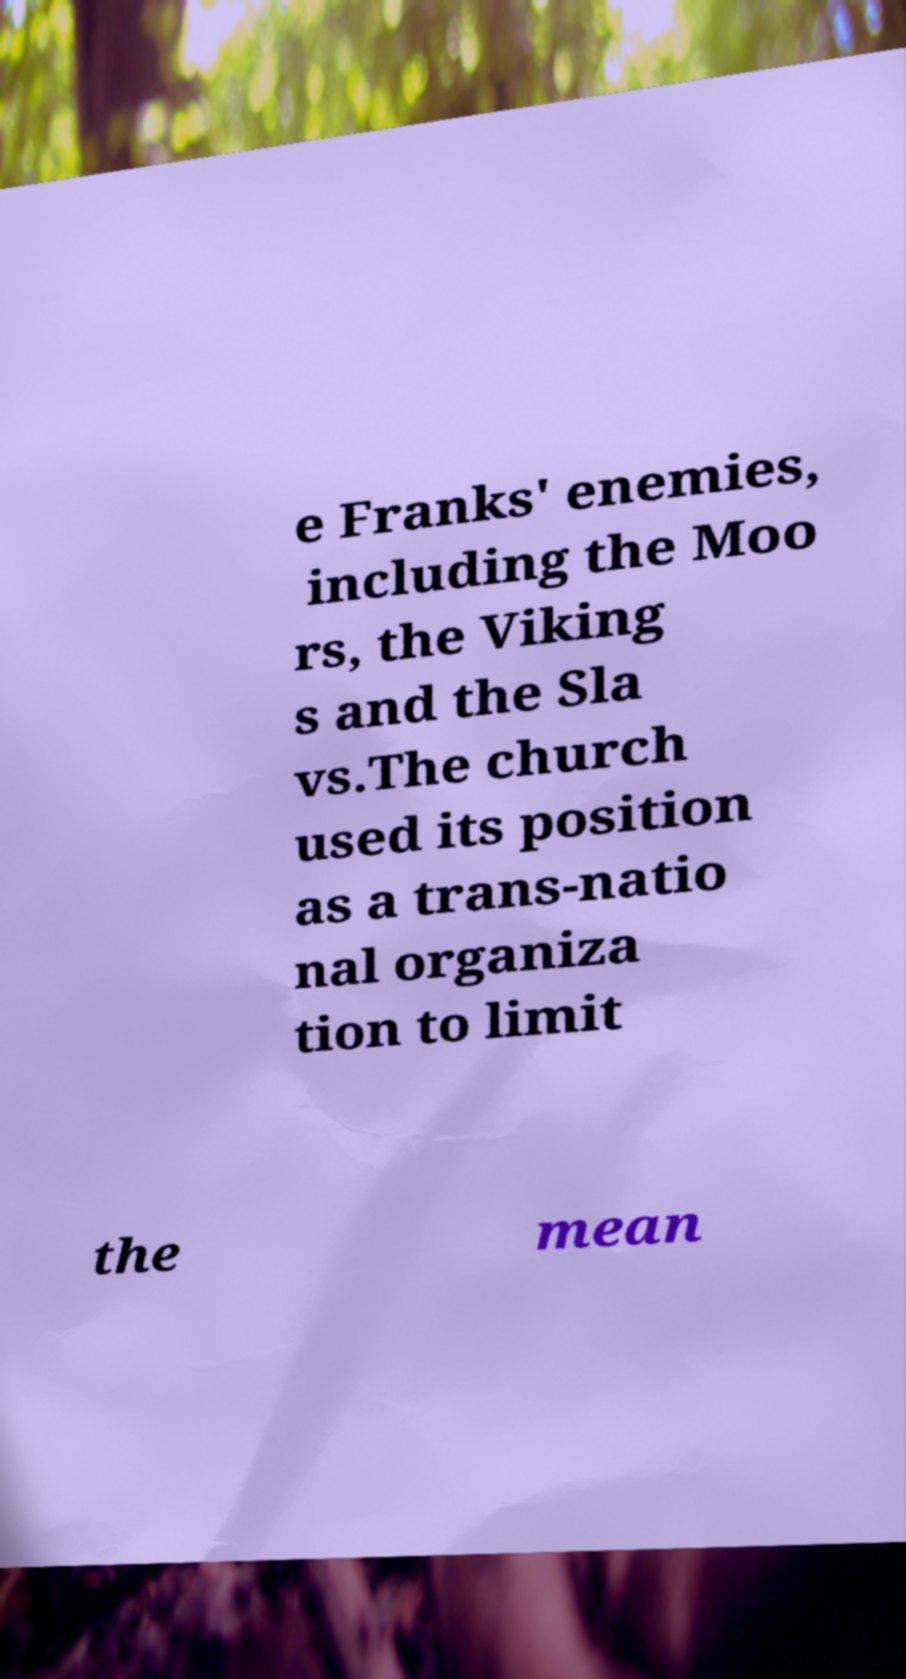I need the written content from this picture converted into text. Can you do that? e Franks' enemies, including the Moo rs, the Viking s and the Sla vs.The church used its position as a trans-natio nal organiza tion to limit the mean 